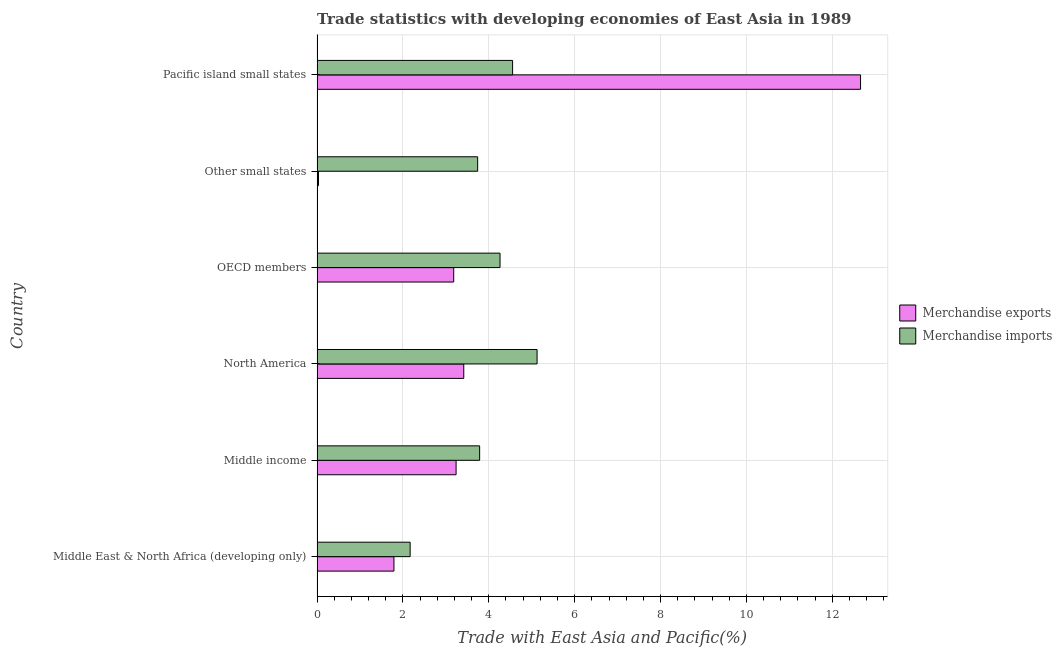How many groups of bars are there?
Keep it short and to the point. 6. Are the number of bars per tick equal to the number of legend labels?
Ensure brevity in your answer.  Yes. Are the number of bars on each tick of the Y-axis equal?
Offer a very short reply. Yes. How many bars are there on the 2nd tick from the top?
Make the answer very short. 2. How many bars are there on the 4th tick from the bottom?
Offer a terse response. 2. What is the label of the 2nd group of bars from the top?
Your response must be concise. Other small states. In how many cases, is the number of bars for a given country not equal to the number of legend labels?
Your answer should be very brief. 0. What is the merchandise exports in Pacific island small states?
Your response must be concise. 12.66. Across all countries, what is the maximum merchandise imports?
Offer a very short reply. 5.12. Across all countries, what is the minimum merchandise imports?
Keep it short and to the point. 2.17. In which country was the merchandise exports maximum?
Your answer should be very brief. Pacific island small states. In which country was the merchandise imports minimum?
Your answer should be very brief. Middle East & North Africa (developing only). What is the total merchandise exports in the graph?
Your answer should be very brief. 24.32. What is the difference between the merchandise imports in North America and that in Other small states?
Provide a succinct answer. 1.38. What is the difference between the merchandise imports in Middle East & North Africa (developing only) and the merchandise exports in Other small states?
Ensure brevity in your answer.  2.13. What is the average merchandise exports per country?
Provide a short and direct response. 4.05. What is the difference between the merchandise exports and merchandise imports in OECD members?
Make the answer very short. -1.08. In how many countries, is the merchandise exports greater than 3.6 %?
Give a very brief answer. 1. What is the ratio of the merchandise imports in North America to that in OECD members?
Your answer should be very brief. 1.2. What is the difference between the highest and the second highest merchandise exports?
Offer a terse response. 9.24. What is the difference between the highest and the lowest merchandise exports?
Make the answer very short. 12.62. What does the 2nd bar from the top in Middle income represents?
Keep it short and to the point. Merchandise exports. What does the 1st bar from the bottom in North America represents?
Ensure brevity in your answer.  Merchandise exports. Are all the bars in the graph horizontal?
Your response must be concise. Yes. What is the difference between two consecutive major ticks on the X-axis?
Ensure brevity in your answer.  2. Does the graph contain any zero values?
Your answer should be compact. No. Does the graph contain grids?
Make the answer very short. Yes. What is the title of the graph?
Offer a very short reply. Trade statistics with developing economies of East Asia in 1989. Does "Arms imports" appear as one of the legend labels in the graph?
Give a very brief answer. No. What is the label or title of the X-axis?
Keep it short and to the point. Trade with East Asia and Pacific(%). What is the label or title of the Y-axis?
Your answer should be very brief. Country. What is the Trade with East Asia and Pacific(%) in Merchandise exports in Middle East & North Africa (developing only)?
Provide a short and direct response. 1.79. What is the Trade with East Asia and Pacific(%) in Merchandise imports in Middle East & North Africa (developing only)?
Give a very brief answer. 2.17. What is the Trade with East Asia and Pacific(%) of Merchandise exports in Middle income?
Offer a terse response. 3.24. What is the Trade with East Asia and Pacific(%) of Merchandise imports in Middle income?
Ensure brevity in your answer.  3.79. What is the Trade with East Asia and Pacific(%) in Merchandise exports in North America?
Provide a succinct answer. 3.42. What is the Trade with East Asia and Pacific(%) of Merchandise imports in North America?
Make the answer very short. 5.12. What is the Trade with East Asia and Pacific(%) in Merchandise exports in OECD members?
Provide a succinct answer. 3.18. What is the Trade with East Asia and Pacific(%) of Merchandise imports in OECD members?
Provide a short and direct response. 4.26. What is the Trade with East Asia and Pacific(%) of Merchandise exports in Other small states?
Provide a succinct answer. 0.03. What is the Trade with East Asia and Pacific(%) of Merchandise imports in Other small states?
Make the answer very short. 3.74. What is the Trade with East Asia and Pacific(%) in Merchandise exports in Pacific island small states?
Ensure brevity in your answer.  12.66. What is the Trade with East Asia and Pacific(%) of Merchandise imports in Pacific island small states?
Offer a very short reply. 4.55. Across all countries, what is the maximum Trade with East Asia and Pacific(%) of Merchandise exports?
Ensure brevity in your answer.  12.66. Across all countries, what is the maximum Trade with East Asia and Pacific(%) of Merchandise imports?
Give a very brief answer. 5.12. Across all countries, what is the minimum Trade with East Asia and Pacific(%) in Merchandise exports?
Give a very brief answer. 0.03. Across all countries, what is the minimum Trade with East Asia and Pacific(%) of Merchandise imports?
Offer a terse response. 2.17. What is the total Trade with East Asia and Pacific(%) of Merchandise exports in the graph?
Your answer should be very brief. 24.32. What is the total Trade with East Asia and Pacific(%) in Merchandise imports in the graph?
Your answer should be very brief. 23.64. What is the difference between the Trade with East Asia and Pacific(%) of Merchandise exports in Middle East & North Africa (developing only) and that in Middle income?
Make the answer very short. -1.45. What is the difference between the Trade with East Asia and Pacific(%) in Merchandise imports in Middle East & North Africa (developing only) and that in Middle income?
Your answer should be very brief. -1.62. What is the difference between the Trade with East Asia and Pacific(%) of Merchandise exports in Middle East & North Africa (developing only) and that in North America?
Give a very brief answer. -1.63. What is the difference between the Trade with East Asia and Pacific(%) of Merchandise imports in Middle East & North Africa (developing only) and that in North America?
Your response must be concise. -2.96. What is the difference between the Trade with East Asia and Pacific(%) in Merchandise exports in Middle East & North Africa (developing only) and that in OECD members?
Give a very brief answer. -1.39. What is the difference between the Trade with East Asia and Pacific(%) in Merchandise imports in Middle East & North Africa (developing only) and that in OECD members?
Offer a terse response. -2.09. What is the difference between the Trade with East Asia and Pacific(%) of Merchandise exports in Middle East & North Africa (developing only) and that in Other small states?
Your answer should be compact. 1.76. What is the difference between the Trade with East Asia and Pacific(%) in Merchandise imports in Middle East & North Africa (developing only) and that in Other small states?
Offer a terse response. -1.57. What is the difference between the Trade with East Asia and Pacific(%) of Merchandise exports in Middle East & North Africa (developing only) and that in Pacific island small states?
Offer a terse response. -10.87. What is the difference between the Trade with East Asia and Pacific(%) in Merchandise imports in Middle East & North Africa (developing only) and that in Pacific island small states?
Your answer should be compact. -2.39. What is the difference between the Trade with East Asia and Pacific(%) in Merchandise exports in Middle income and that in North America?
Make the answer very short. -0.18. What is the difference between the Trade with East Asia and Pacific(%) of Merchandise imports in Middle income and that in North America?
Offer a terse response. -1.34. What is the difference between the Trade with East Asia and Pacific(%) in Merchandise exports in Middle income and that in OECD members?
Ensure brevity in your answer.  0.06. What is the difference between the Trade with East Asia and Pacific(%) of Merchandise imports in Middle income and that in OECD members?
Make the answer very short. -0.47. What is the difference between the Trade with East Asia and Pacific(%) in Merchandise exports in Middle income and that in Other small states?
Provide a succinct answer. 3.2. What is the difference between the Trade with East Asia and Pacific(%) in Merchandise imports in Middle income and that in Other small states?
Offer a terse response. 0.05. What is the difference between the Trade with East Asia and Pacific(%) of Merchandise exports in Middle income and that in Pacific island small states?
Give a very brief answer. -9.42. What is the difference between the Trade with East Asia and Pacific(%) in Merchandise imports in Middle income and that in Pacific island small states?
Offer a terse response. -0.77. What is the difference between the Trade with East Asia and Pacific(%) in Merchandise exports in North America and that in OECD members?
Your response must be concise. 0.23. What is the difference between the Trade with East Asia and Pacific(%) of Merchandise imports in North America and that in OECD members?
Keep it short and to the point. 0.86. What is the difference between the Trade with East Asia and Pacific(%) in Merchandise exports in North America and that in Other small states?
Make the answer very short. 3.38. What is the difference between the Trade with East Asia and Pacific(%) of Merchandise imports in North America and that in Other small states?
Ensure brevity in your answer.  1.38. What is the difference between the Trade with East Asia and Pacific(%) of Merchandise exports in North America and that in Pacific island small states?
Your response must be concise. -9.24. What is the difference between the Trade with East Asia and Pacific(%) in Merchandise imports in North America and that in Pacific island small states?
Your response must be concise. 0.57. What is the difference between the Trade with East Asia and Pacific(%) of Merchandise exports in OECD members and that in Other small states?
Keep it short and to the point. 3.15. What is the difference between the Trade with East Asia and Pacific(%) in Merchandise imports in OECD members and that in Other small states?
Make the answer very short. 0.52. What is the difference between the Trade with East Asia and Pacific(%) in Merchandise exports in OECD members and that in Pacific island small states?
Your answer should be very brief. -9.48. What is the difference between the Trade with East Asia and Pacific(%) in Merchandise imports in OECD members and that in Pacific island small states?
Offer a terse response. -0.29. What is the difference between the Trade with East Asia and Pacific(%) in Merchandise exports in Other small states and that in Pacific island small states?
Ensure brevity in your answer.  -12.62. What is the difference between the Trade with East Asia and Pacific(%) of Merchandise imports in Other small states and that in Pacific island small states?
Your response must be concise. -0.81. What is the difference between the Trade with East Asia and Pacific(%) in Merchandise exports in Middle East & North Africa (developing only) and the Trade with East Asia and Pacific(%) in Merchandise imports in Middle income?
Keep it short and to the point. -2. What is the difference between the Trade with East Asia and Pacific(%) in Merchandise exports in Middle East & North Africa (developing only) and the Trade with East Asia and Pacific(%) in Merchandise imports in North America?
Make the answer very short. -3.33. What is the difference between the Trade with East Asia and Pacific(%) of Merchandise exports in Middle East & North Africa (developing only) and the Trade with East Asia and Pacific(%) of Merchandise imports in OECD members?
Provide a succinct answer. -2.47. What is the difference between the Trade with East Asia and Pacific(%) of Merchandise exports in Middle East & North Africa (developing only) and the Trade with East Asia and Pacific(%) of Merchandise imports in Other small states?
Make the answer very short. -1.95. What is the difference between the Trade with East Asia and Pacific(%) of Merchandise exports in Middle East & North Africa (developing only) and the Trade with East Asia and Pacific(%) of Merchandise imports in Pacific island small states?
Make the answer very short. -2.76. What is the difference between the Trade with East Asia and Pacific(%) of Merchandise exports in Middle income and the Trade with East Asia and Pacific(%) of Merchandise imports in North America?
Your response must be concise. -1.89. What is the difference between the Trade with East Asia and Pacific(%) of Merchandise exports in Middle income and the Trade with East Asia and Pacific(%) of Merchandise imports in OECD members?
Provide a succinct answer. -1.02. What is the difference between the Trade with East Asia and Pacific(%) of Merchandise exports in Middle income and the Trade with East Asia and Pacific(%) of Merchandise imports in Other small states?
Your response must be concise. -0.5. What is the difference between the Trade with East Asia and Pacific(%) of Merchandise exports in Middle income and the Trade with East Asia and Pacific(%) of Merchandise imports in Pacific island small states?
Your answer should be compact. -1.32. What is the difference between the Trade with East Asia and Pacific(%) in Merchandise exports in North America and the Trade with East Asia and Pacific(%) in Merchandise imports in OECD members?
Your response must be concise. -0.84. What is the difference between the Trade with East Asia and Pacific(%) of Merchandise exports in North America and the Trade with East Asia and Pacific(%) of Merchandise imports in Other small states?
Your answer should be compact. -0.32. What is the difference between the Trade with East Asia and Pacific(%) in Merchandise exports in North America and the Trade with East Asia and Pacific(%) in Merchandise imports in Pacific island small states?
Provide a short and direct response. -1.14. What is the difference between the Trade with East Asia and Pacific(%) of Merchandise exports in OECD members and the Trade with East Asia and Pacific(%) of Merchandise imports in Other small states?
Offer a very short reply. -0.56. What is the difference between the Trade with East Asia and Pacific(%) in Merchandise exports in OECD members and the Trade with East Asia and Pacific(%) in Merchandise imports in Pacific island small states?
Keep it short and to the point. -1.37. What is the difference between the Trade with East Asia and Pacific(%) of Merchandise exports in Other small states and the Trade with East Asia and Pacific(%) of Merchandise imports in Pacific island small states?
Your response must be concise. -4.52. What is the average Trade with East Asia and Pacific(%) of Merchandise exports per country?
Keep it short and to the point. 4.05. What is the average Trade with East Asia and Pacific(%) in Merchandise imports per country?
Your answer should be very brief. 3.94. What is the difference between the Trade with East Asia and Pacific(%) of Merchandise exports and Trade with East Asia and Pacific(%) of Merchandise imports in Middle East & North Africa (developing only)?
Offer a terse response. -0.38. What is the difference between the Trade with East Asia and Pacific(%) of Merchandise exports and Trade with East Asia and Pacific(%) of Merchandise imports in Middle income?
Your answer should be compact. -0.55. What is the difference between the Trade with East Asia and Pacific(%) of Merchandise exports and Trade with East Asia and Pacific(%) of Merchandise imports in North America?
Give a very brief answer. -1.71. What is the difference between the Trade with East Asia and Pacific(%) of Merchandise exports and Trade with East Asia and Pacific(%) of Merchandise imports in OECD members?
Make the answer very short. -1.08. What is the difference between the Trade with East Asia and Pacific(%) in Merchandise exports and Trade with East Asia and Pacific(%) in Merchandise imports in Other small states?
Your response must be concise. -3.71. What is the difference between the Trade with East Asia and Pacific(%) of Merchandise exports and Trade with East Asia and Pacific(%) of Merchandise imports in Pacific island small states?
Offer a very short reply. 8.1. What is the ratio of the Trade with East Asia and Pacific(%) of Merchandise exports in Middle East & North Africa (developing only) to that in Middle income?
Ensure brevity in your answer.  0.55. What is the ratio of the Trade with East Asia and Pacific(%) of Merchandise imports in Middle East & North Africa (developing only) to that in Middle income?
Keep it short and to the point. 0.57. What is the ratio of the Trade with East Asia and Pacific(%) in Merchandise exports in Middle East & North Africa (developing only) to that in North America?
Your answer should be compact. 0.52. What is the ratio of the Trade with East Asia and Pacific(%) in Merchandise imports in Middle East & North Africa (developing only) to that in North America?
Provide a short and direct response. 0.42. What is the ratio of the Trade with East Asia and Pacific(%) in Merchandise exports in Middle East & North Africa (developing only) to that in OECD members?
Offer a terse response. 0.56. What is the ratio of the Trade with East Asia and Pacific(%) of Merchandise imports in Middle East & North Africa (developing only) to that in OECD members?
Offer a very short reply. 0.51. What is the ratio of the Trade with East Asia and Pacific(%) in Merchandise exports in Middle East & North Africa (developing only) to that in Other small states?
Offer a terse response. 53.33. What is the ratio of the Trade with East Asia and Pacific(%) of Merchandise imports in Middle East & North Africa (developing only) to that in Other small states?
Ensure brevity in your answer.  0.58. What is the ratio of the Trade with East Asia and Pacific(%) of Merchandise exports in Middle East & North Africa (developing only) to that in Pacific island small states?
Your answer should be very brief. 0.14. What is the ratio of the Trade with East Asia and Pacific(%) in Merchandise imports in Middle East & North Africa (developing only) to that in Pacific island small states?
Your answer should be compact. 0.48. What is the ratio of the Trade with East Asia and Pacific(%) of Merchandise exports in Middle income to that in North America?
Keep it short and to the point. 0.95. What is the ratio of the Trade with East Asia and Pacific(%) in Merchandise imports in Middle income to that in North America?
Offer a terse response. 0.74. What is the ratio of the Trade with East Asia and Pacific(%) in Merchandise exports in Middle income to that in OECD members?
Keep it short and to the point. 1.02. What is the ratio of the Trade with East Asia and Pacific(%) of Merchandise imports in Middle income to that in OECD members?
Ensure brevity in your answer.  0.89. What is the ratio of the Trade with East Asia and Pacific(%) in Merchandise exports in Middle income to that in Other small states?
Offer a terse response. 96.44. What is the ratio of the Trade with East Asia and Pacific(%) in Merchandise imports in Middle income to that in Other small states?
Provide a succinct answer. 1.01. What is the ratio of the Trade with East Asia and Pacific(%) of Merchandise exports in Middle income to that in Pacific island small states?
Make the answer very short. 0.26. What is the ratio of the Trade with East Asia and Pacific(%) of Merchandise imports in Middle income to that in Pacific island small states?
Provide a succinct answer. 0.83. What is the ratio of the Trade with East Asia and Pacific(%) in Merchandise exports in North America to that in OECD members?
Make the answer very short. 1.07. What is the ratio of the Trade with East Asia and Pacific(%) in Merchandise imports in North America to that in OECD members?
Give a very brief answer. 1.2. What is the ratio of the Trade with East Asia and Pacific(%) of Merchandise exports in North America to that in Other small states?
Offer a very short reply. 101.75. What is the ratio of the Trade with East Asia and Pacific(%) in Merchandise imports in North America to that in Other small states?
Give a very brief answer. 1.37. What is the ratio of the Trade with East Asia and Pacific(%) in Merchandise exports in North America to that in Pacific island small states?
Give a very brief answer. 0.27. What is the ratio of the Trade with East Asia and Pacific(%) of Merchandise imports in North America to that in Pacific island small states?
Make the answer very short. 1.13. What is the ratio of the Trade with East Asia and Pacific(%) of Merchandise exports in OECD members to that in Other small states?
Provide a short and direct response. 94.78. What is the ratio of the Trade with East Asia and Pacific(%) of Merchandise imports in OECD members to that in Other small states?
Provide a short and direct response. 1.14. What is the ratio of the Trade with East Asia and Pacific(%) in Merchandise exports in OECD members to that in Pacific island small states?
Keep it short and to the point. 0.25. What is the ratio of the Trade with East Asia and Pacific(%) of Merchandise imports in OECD members to that in Pacific island small states?
Your answer should be compact. 0.94. What is the ratio of the Trade with East Asia and Pacific(%) in Merchandise exports in Other small states to that in Pacific island small states?
Ensure brevity in your answer.  0. What is the ratio of the Trade with East Asia and Pacific(%) of Merchandise imports in Other small states to that in Pacific island small states?
Ensure brevity in your answer.  0.82. What is the difference between the highest and the second highest Trade with East Asia and Pacific(%) of Merchandise exports?
Provide a short and direct response. 9.24. What is the difference between the highest and the second highest Trade with East Asia and Pacific(%) in Merchandise imports?
Your response must be concise. 0.57. What is the difference between the highest and the lowest Trade with East Asia and Pacific(%) of Merchandise exports?
Your answer should be very brief. 12.62. What is the difference between the highest and the lowest Trade with East Asia and Pacific(%) of Merchandise imports?
Offer a very short reply. 2.96. 